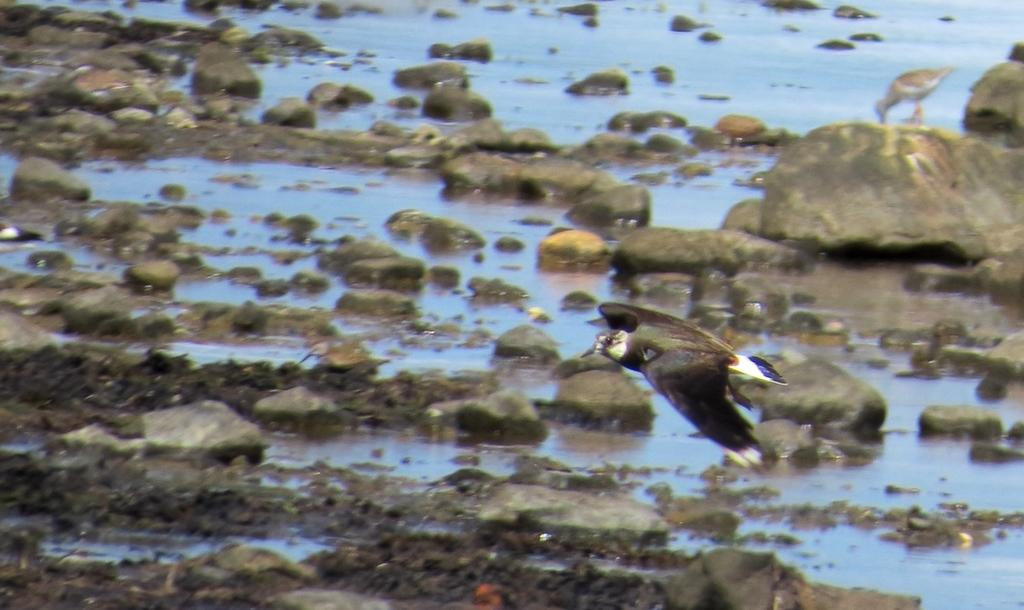What is happening in the sky in the image? There is a bird flying in the sky. What can be seen on the ground in the image? There is water and mud visible on the ground, as well as rocks. Can you describe the bird's activity in the image? The bird is flying in the sky. How many ladybugs can be seen crawling on the rocks in the image? There are no ladybugs present in the image; it features a bird flying in the sky and water, mud, and rocks on the ground. What type of dish is the cook preparing in the image? There is no cook or dish preparation present in the image. 